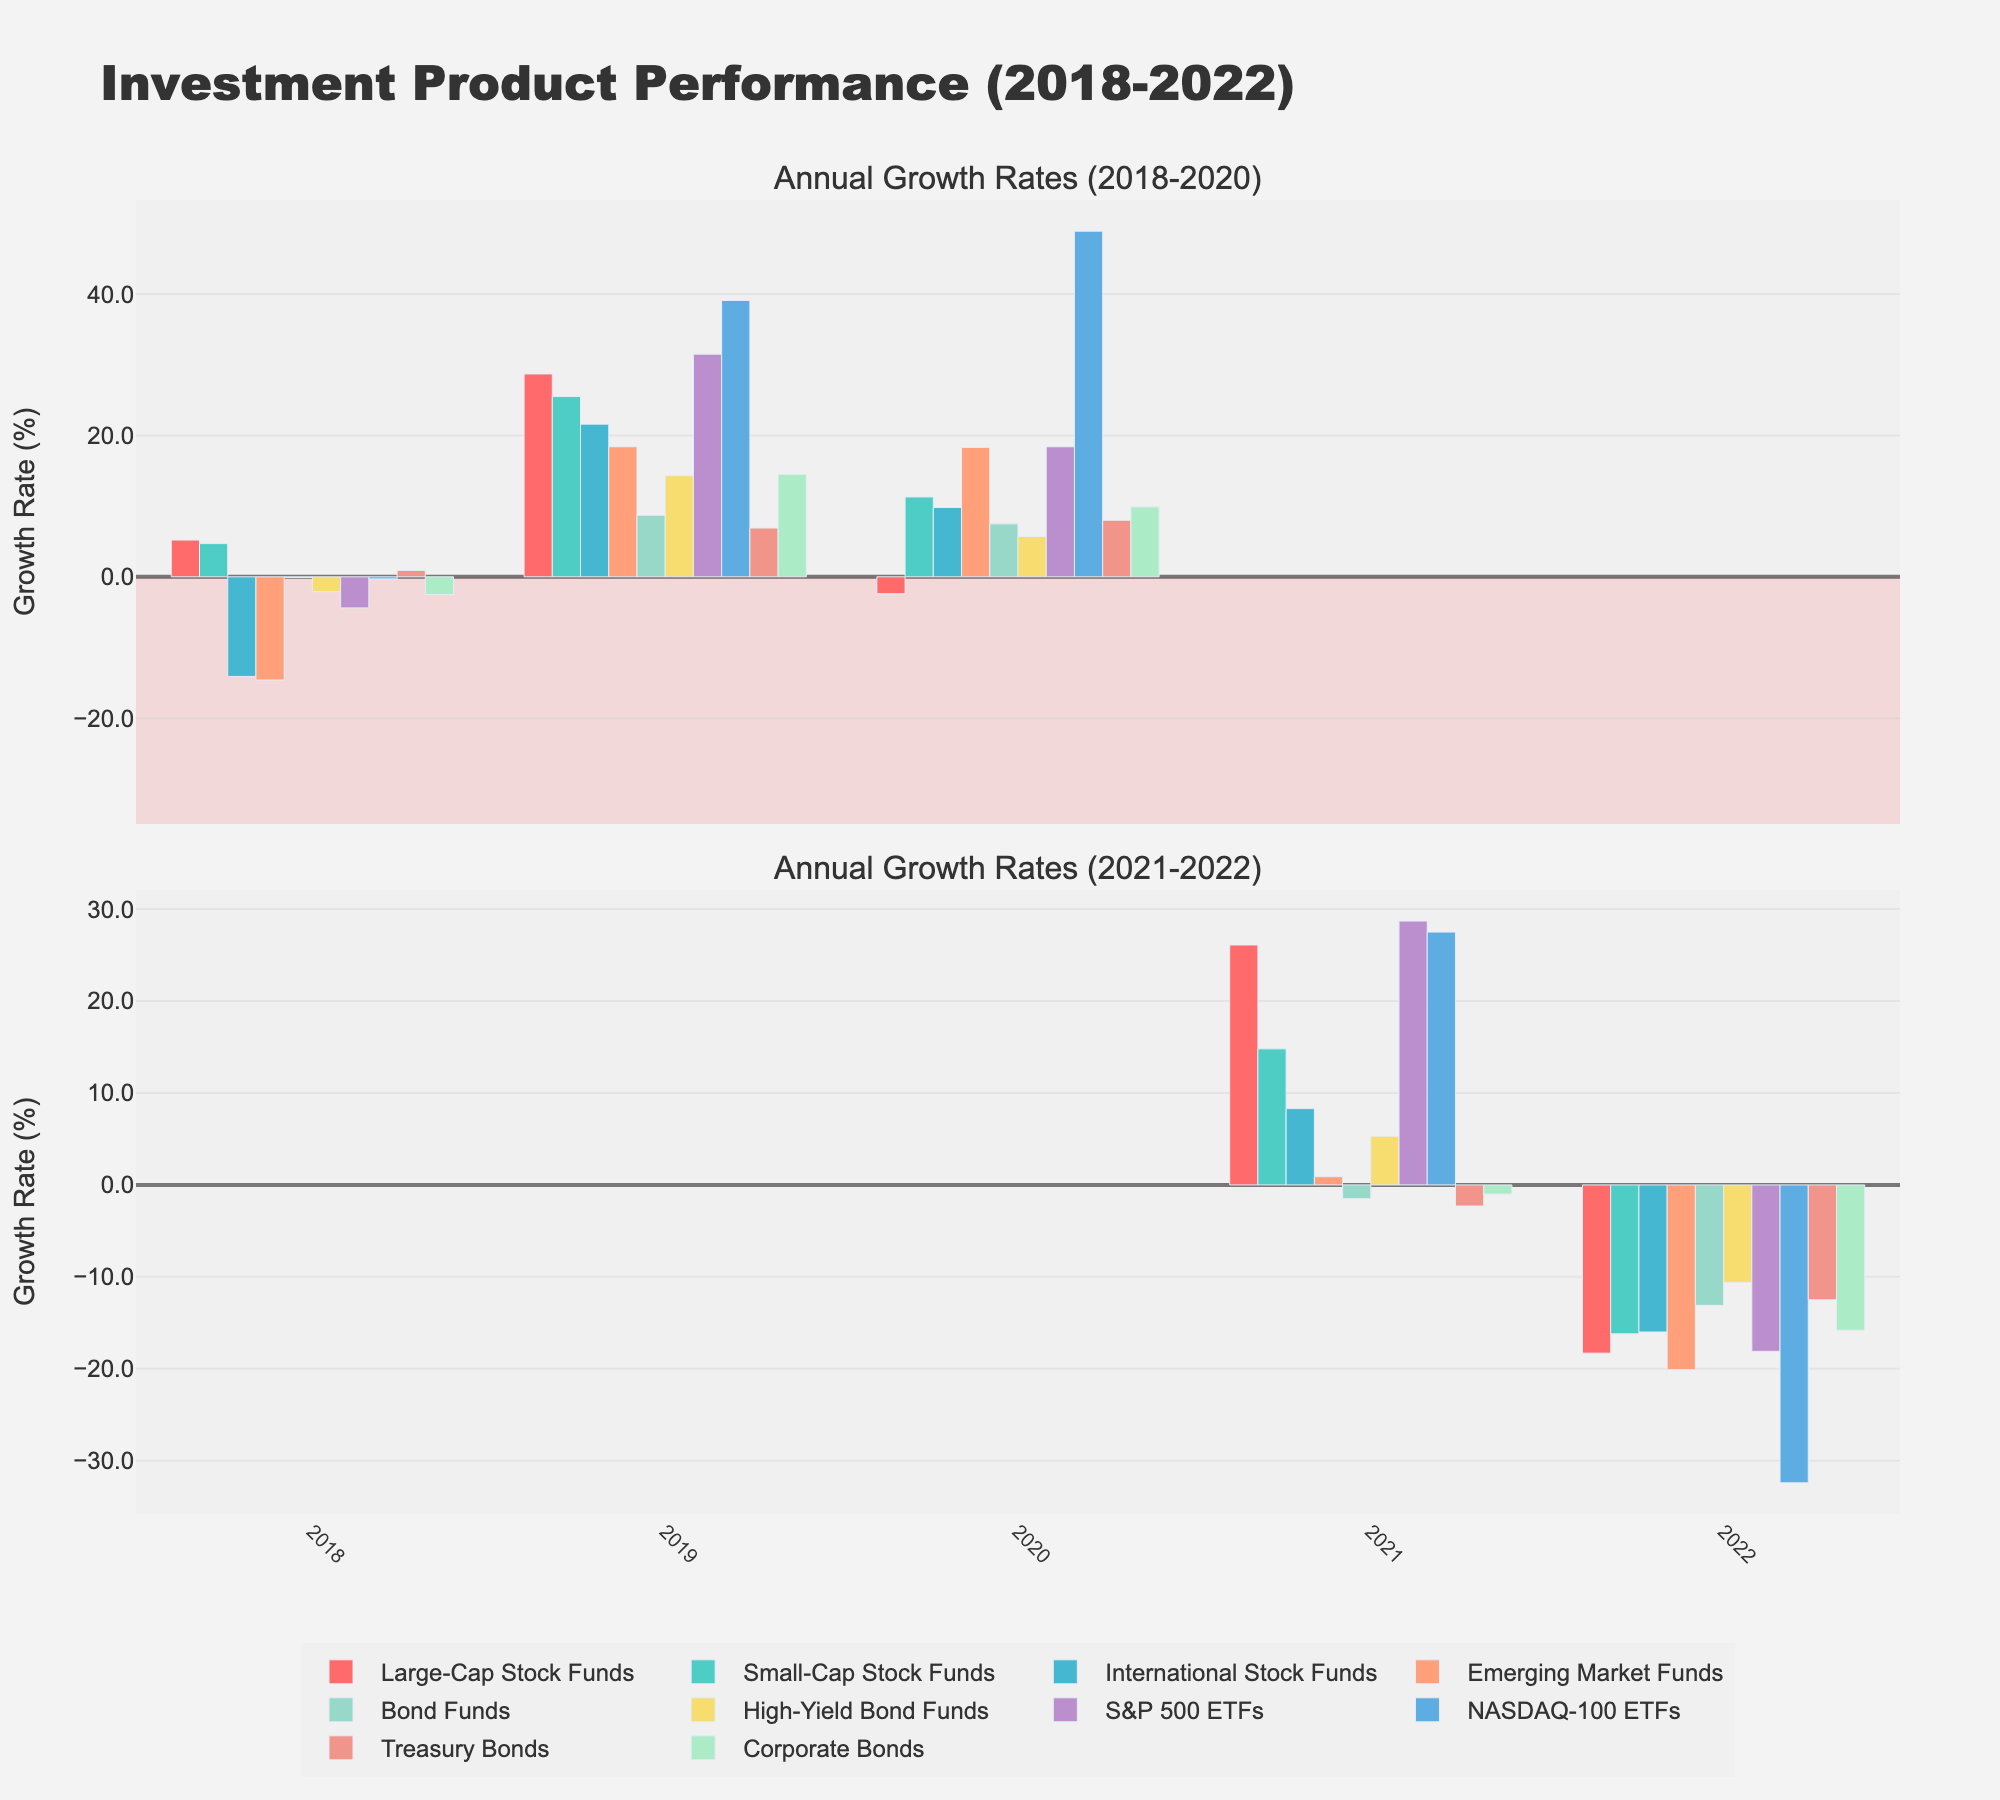What was the highest growth rate for NASDAQ-100 ETFs? By observing the tallest bar associated with the NASDAQ-100 ETFs across the two subplots, we see the highest growth rate is in 2020 with a value of 48.9%.
Answer: 48.9% Which investment type had negative growth for all five years? Looking at the subplots, we notice that Emerging Market Funds had negative values for all the years, from 2018 to 2022.
Answer: Emerging Market Funds In 2020, how did Bond Funds perform relative to Corporate Bonds? The bar for Bond Funds in 2020 reaches 7.5%, while the bar for Corporate Bonds in 2020 reaches 9.9%, indicating Corporate Bonds had a higher growth rate in 2020.
Answer: Corporate Bonds performed better What's the average growth rate for S&P 500 ETFs over the first three years? S&P 500 ETFs growth rates from 2018 to 2020 are -4.4, 31.5, and 18.4. Summing these values and dividing by 3 gives \((-4.4 + 31.5 + 18.4)/3 = 15.17\).
Answer: 15.17% Which investment types experienced their highest growth in 2021? By observing which bars are the tallest in the 2021 subplot, Large-Cap Stock Funds (26.1%) and S&P 500 ETFs (28.7%) had their highest growth rates in 2021.
Answer: Large-Cap Stock Funds, S&P 500 ETFs What's the difference in growth rate between Large-Cap Stock Funds and International Stock Funds in 2019? In 2019, Large-Cap Stock Funds had a growth rate of 28.7% and International Stock Funds had 21.6%. Calculating the difference, \(28.7 - 21.6 = 7.1\).
Answer: 7.1% Which investment type had the most significant decrease in 2022 compared to 2021? By comparing the heights of the bars between 2022 and 2021, NASDAQ-100 ETFs saw the largest drop from 27.5% to -32.4%, which is a difference of \(27.5 - (-32.4) = 59.9\).
Answer: NASDAQ-100 ETFs Are there any investment products that had consecutive positive growth in 2020 and 2021? Scanning for bars in 2020 and 2021 greater than 0%, Small-Cap Stock Funds, International Stock Funds, Bond Funds, High-Yield Bond Funds, S&P 500 ETFs, and NASDAQ-100 ETFs all satisfy this condition.
Answer: Small-Cap Stock Funds, International Stock Funds, Bond Funds, High-Yield Bond Funds, S&P 500 ETFs, NASDAQ-100 ETFs What is the mean growth rate of International Stock Funds over the last three years? International Stock Funds' growth rates for 2020, 2021, and 2022 are 9.8, 8.3, and -16.0. Summing these up and dividing by 3 gives \((9.8 + 8.3 - 16.0)/3 = 0.7\).
Answer: 0.7% 